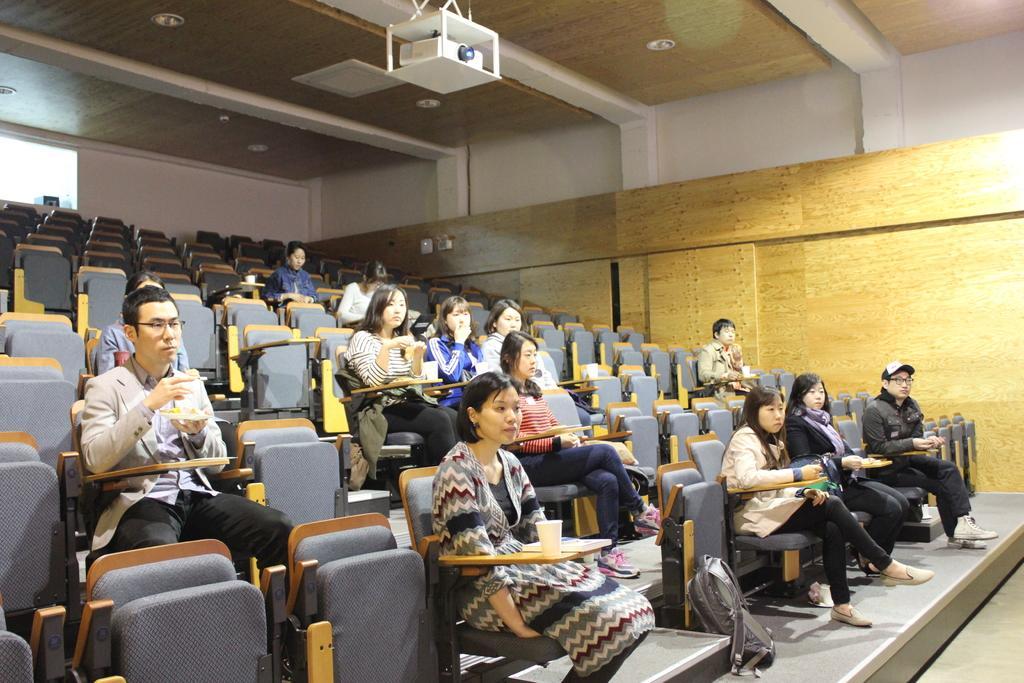How would you summarize this image in a sentence or two? This picture is an inside view of an auditorium. In this picture we can see some persons are sitting on a chair and also we can see cups, books, food item, bags. At the top of the image we can see roof, projector, lights. On the right side of the image there is a wall. At the bottom of the image there is a floor. In the middle of the image we can see some stairs. 